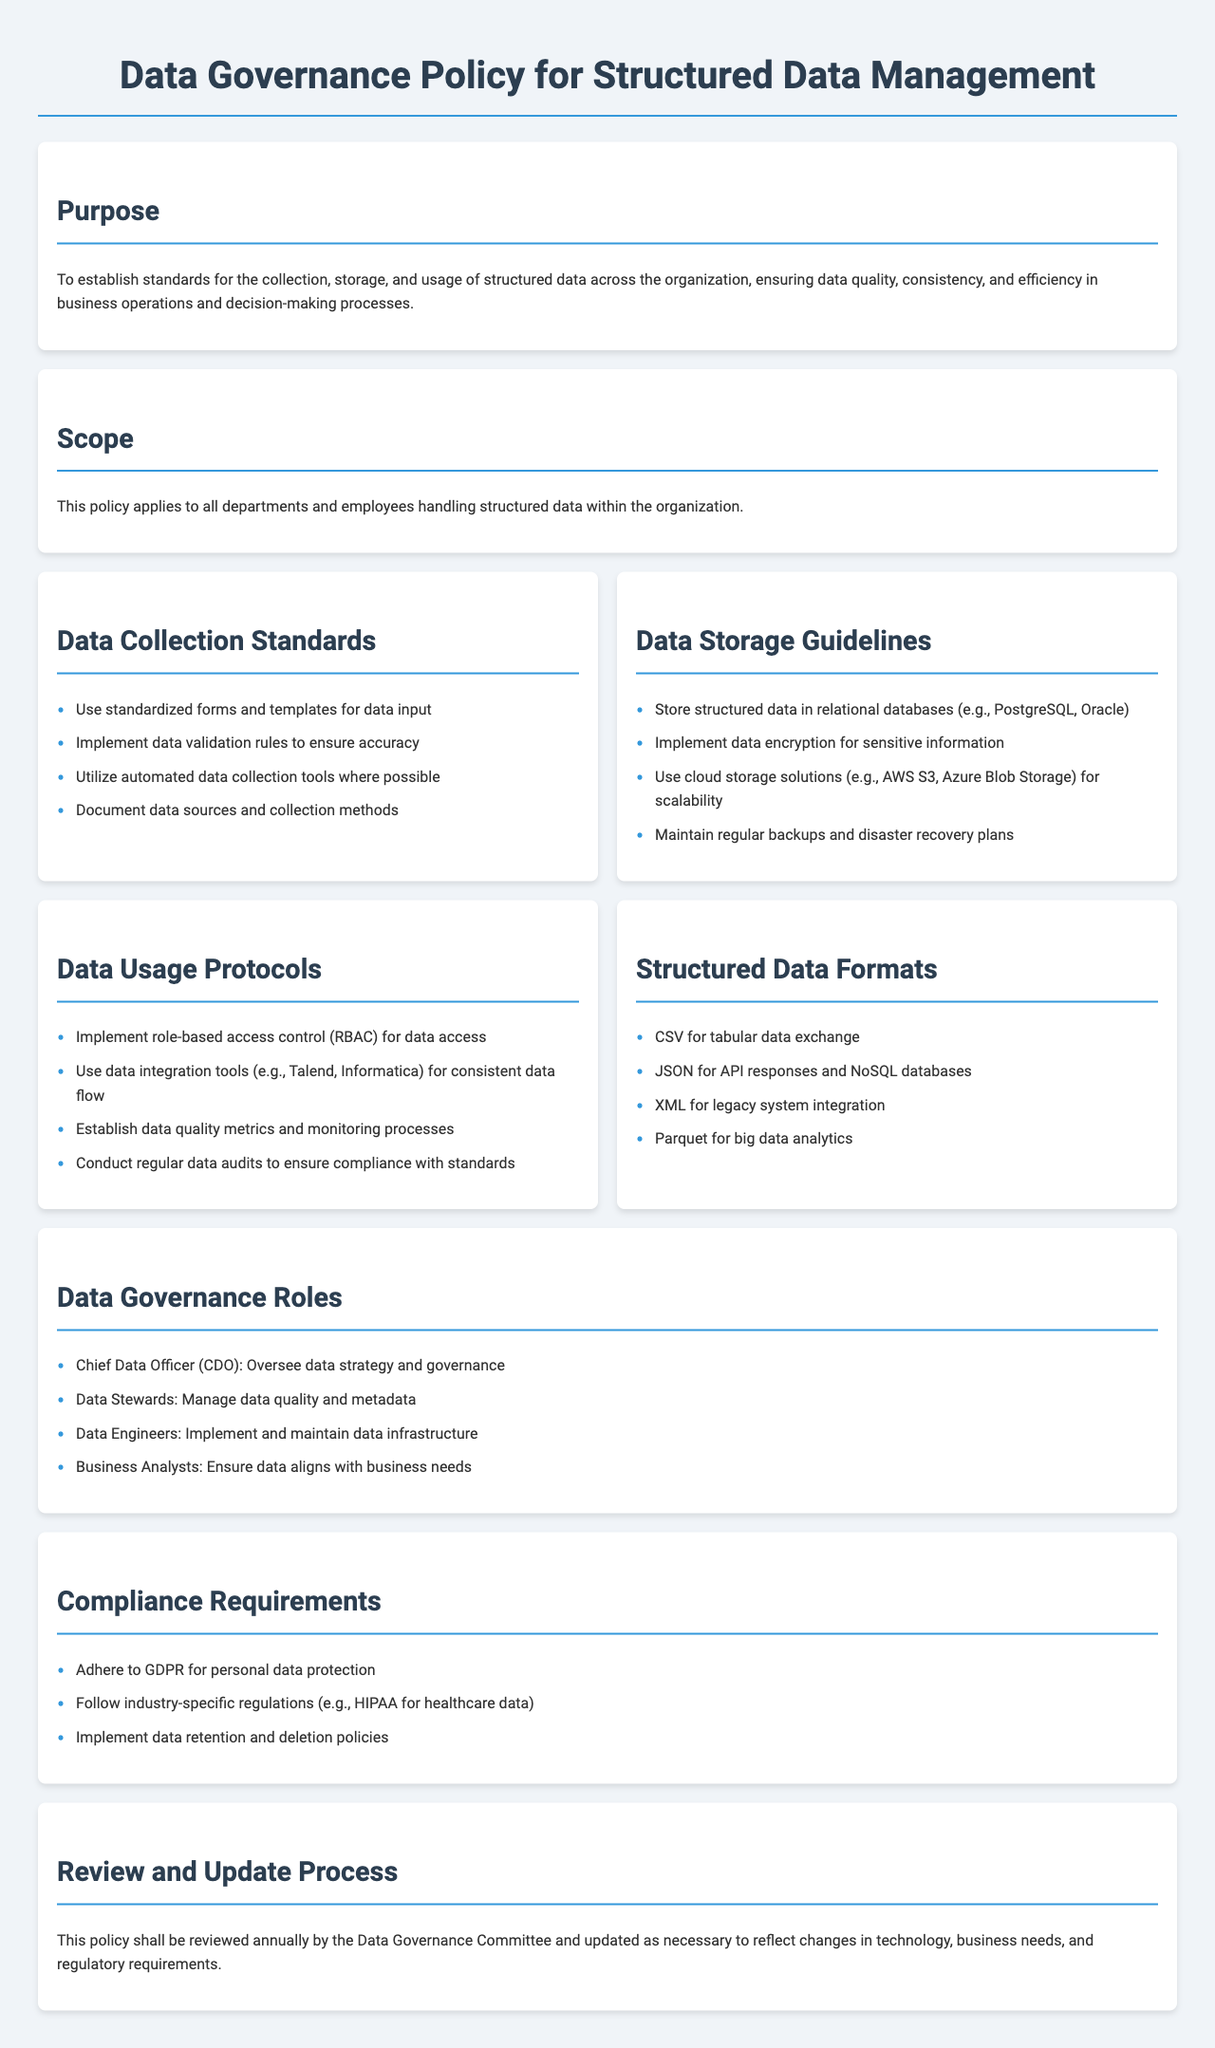What is the purpose of the Data Governance Policy? The purpose outlines the aim to establish standards for data management ensuring quality, consistency, and efficiency.
Answer: To establish standards for the collection, storage, and usage of structured data across the organization, ensuring data quality, consistency, and efficiency in business operations and decision-making processes Who is responsible for overseeing data strategy and governance? This role is specifically mentioned in the governance roles section of the document.
Answer: Chief Data Officer (CDO) What type of storage solution is suggested for sensitive information? This guideline specifies the need for security in data storage practices mentioned in the storage guidelines.
Answer: Data encryption List one structured data format for tabular data exchange. This information can be found in the structured data formats section of the document.
Answer: CSV What does the policy recommend for conducting data audits? This refers to the procedure outlined under data usage protocols.
Answer: Conduct regular data audits to ensure compliance with standards How often should the Data Governance Policy be reviewed? The review frequency is stated in the review process section of the document.
Answer: Annually 